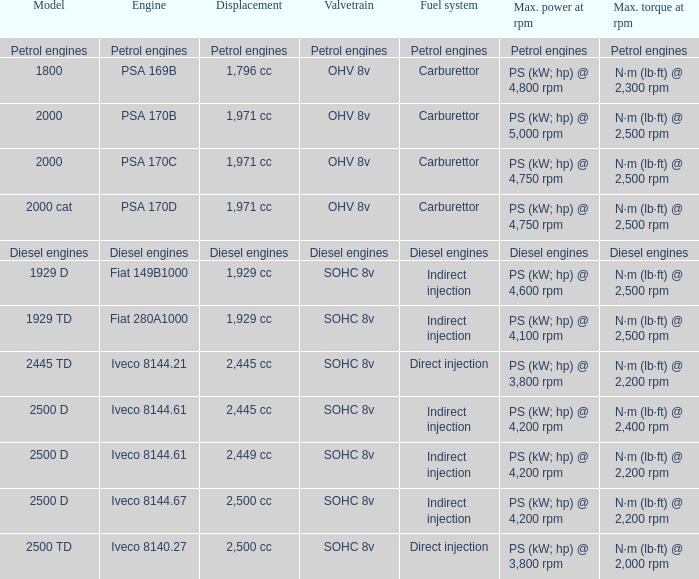What is the top torque achievable with a 2,445 cc displacement and an iveco 814 N·m (lb·ft) @ 2,400 rpm. 